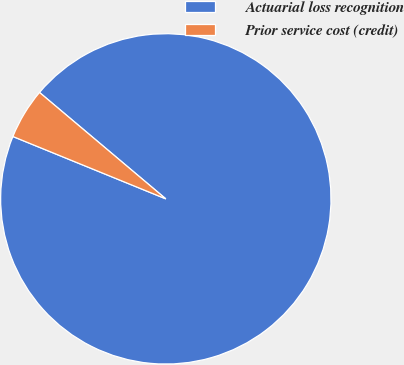Convert chart. <chart><loc_0><loc_0><loc_500><loc_500><pie_chart><fcel>Actuarial loss recognition<fcel>Prior service cost (credit)<nl><fcel>95.02%<fcel>4.98%<nl></chart> 